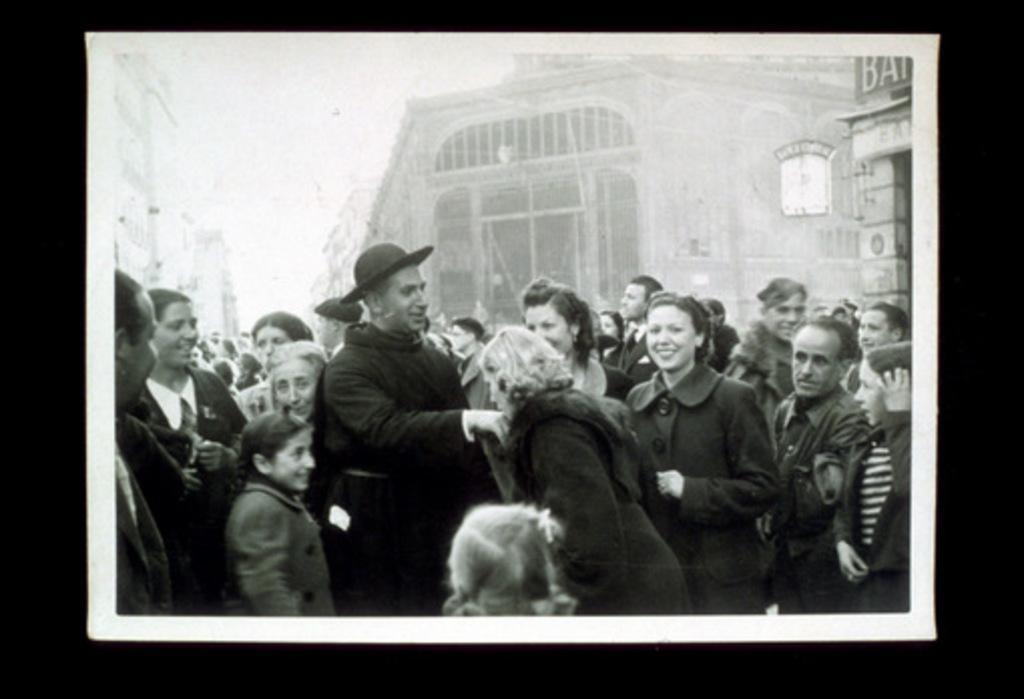Can you describe this image briefly? It is a huge crowd and in between the crowd a woman is kissing the hand of a person. Behind the crowd there are few buildings. 